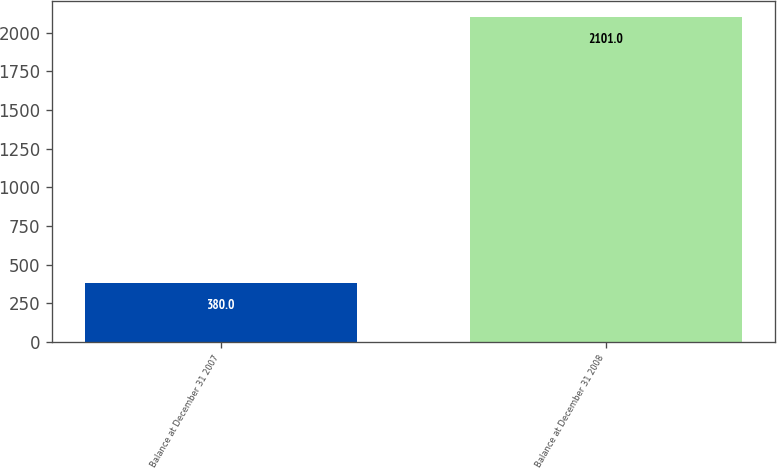Convert chart. <chart><loc_0><loc_0><loc_500><loc_500><bar_chart><fcel>Balance at December 31 2007<fcel>Balance at December 31 2008<nl><fcel>380<fcel>2101<nl></chart> 